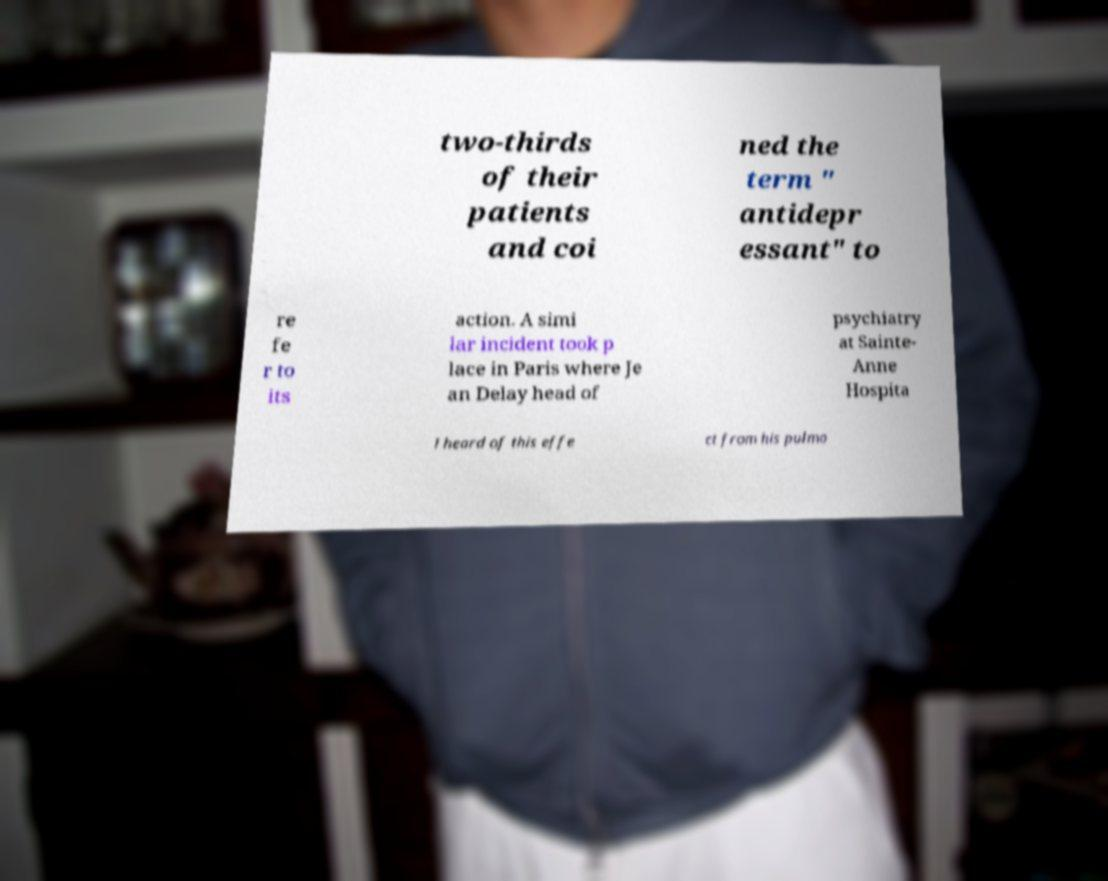Please identify and transcribe the text found in this image. two-thirds of their patients and coi ned the term " antidepr essant" to re fe r to its action. A simi lar incident took p lace in Paris where Je an Delay head of psychiatry at Sainte- Anne Hospita l heard of this effe ct from his pulmo 